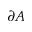<formula> <loc_0><loc_0><loc_500><loc_500>\partial A</formula> 